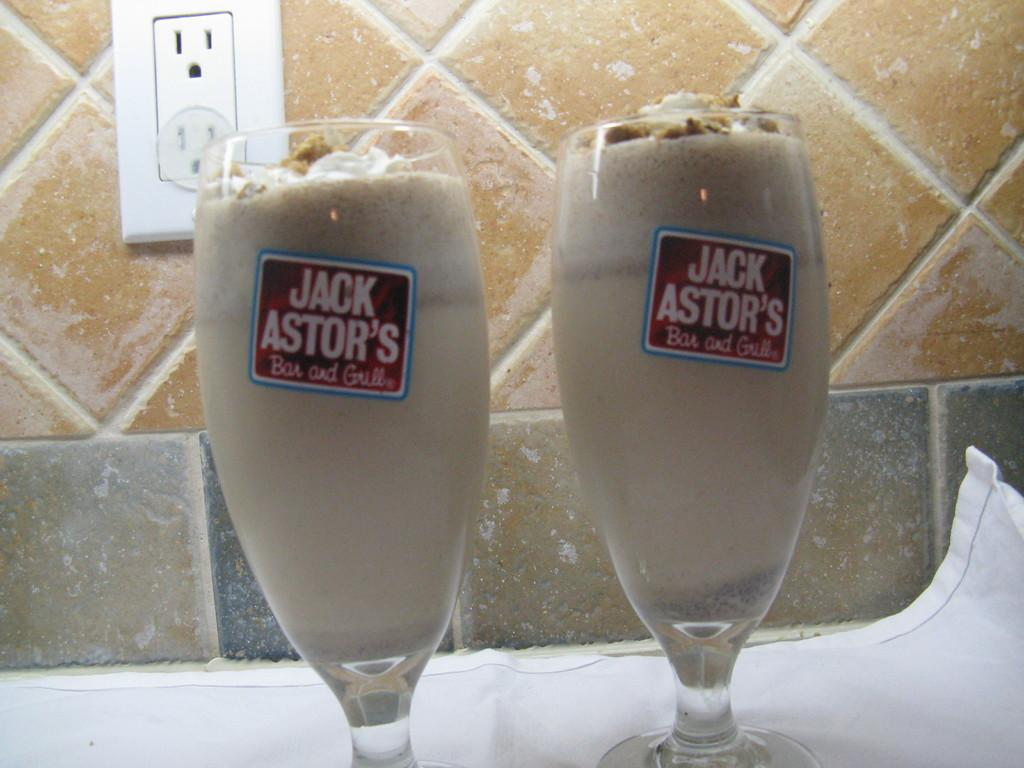How many glasses can be seen in the image? There are two glasses in the image. What is inside the glasses? There is liquid in the glasses. Are there any distinguishing features on the glasses? Yes, the glasses have labels on them. What can be seen in the background of the image? There is a wall visible in the background of the image. Is there a crook trying to open the door of the car in the image? There is no car, door, or crook present in the image. 